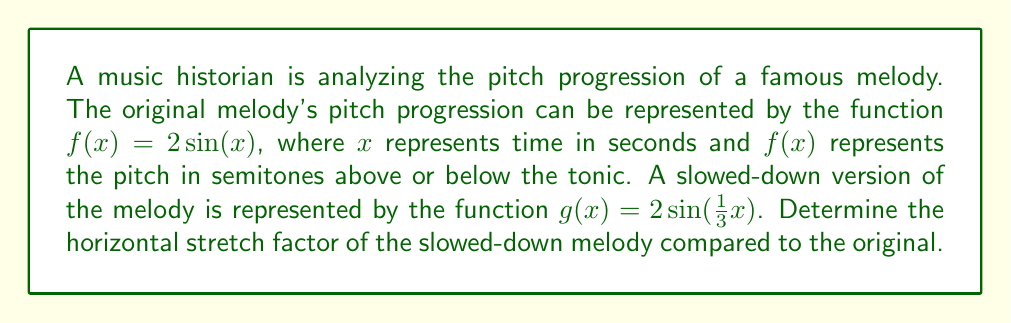Teach me how to tackle this problem. To determine the horizontal stretch factor, we need to compare the functions $f(x)$ and $g(x)$.

1) The original function is $f(x) = 2\sin(x)$
2) The transformed function is $g(x) = 2\sin(\frac{1}{3}x)$

3) The general form of a horizontal stretch is:
   $g(x) = f(\frac{1}{a}x)$, where $a$ is the stretch factor

4) Comparing our $g(x)$ to this general form:
   $2\sin(\frac{1}{3}x) = 2\sin(\frac{1}{a}x)$

5) We can see that $\frac{1}{3} = \frac{1}{a}$

6) Solving for $a$:
   $a = 3$

This means that the graph of $g(x)$ is stretched horizontally by a factor of 3 compared to $f(x)$. In musical terms, this indicates that the slowed-down melody takes 3 times as long to play as the original melody.
Answer: The horizontal stretch factor is 3. 